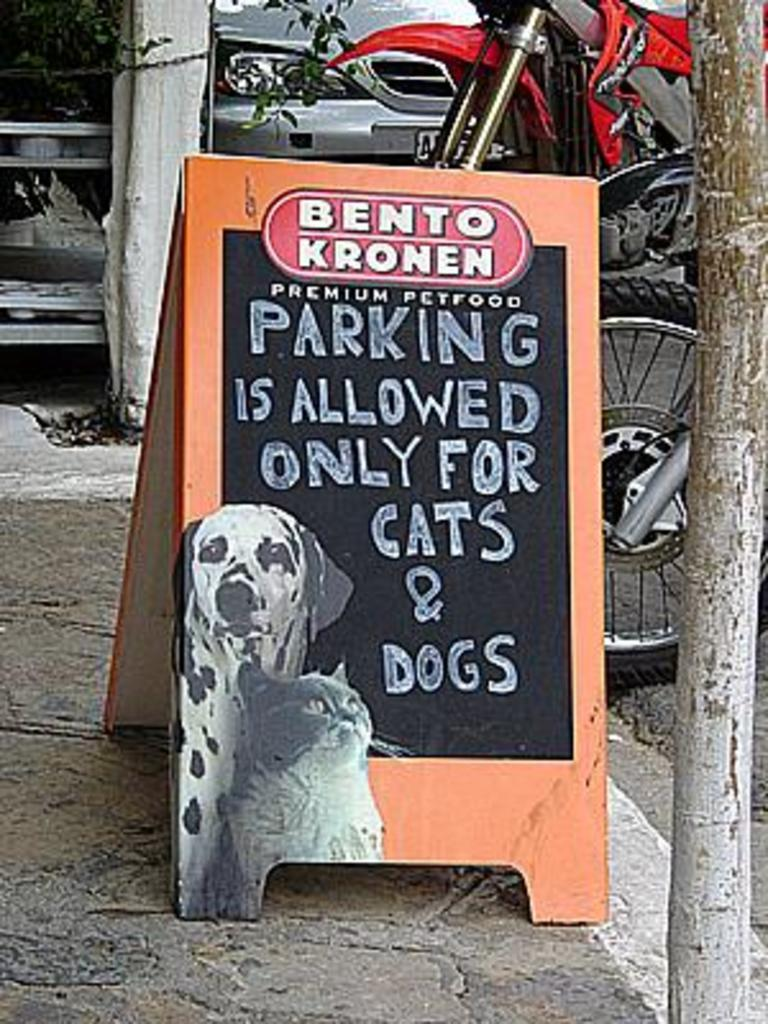What is located on the pavement in the foreground of the image? There is a board on the pavement in the foreground of the image. What objects can be seen supporting the board? There are two wooden poles in the image. What type of vehicle is visible in the image? A motorbike is visible in the image. What other vehicle can be seen in the image? A car is present at the top of the image. How many women are visible in the image? There are no women visible in the image. What type of grip is required to hold the fifth object in the image? There is no fifth object present in the image, so the question of grip is not applicable. 